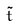<formula> <loc_0><loc_0><loc_500><loc_500>\tilde { t }</formula> 